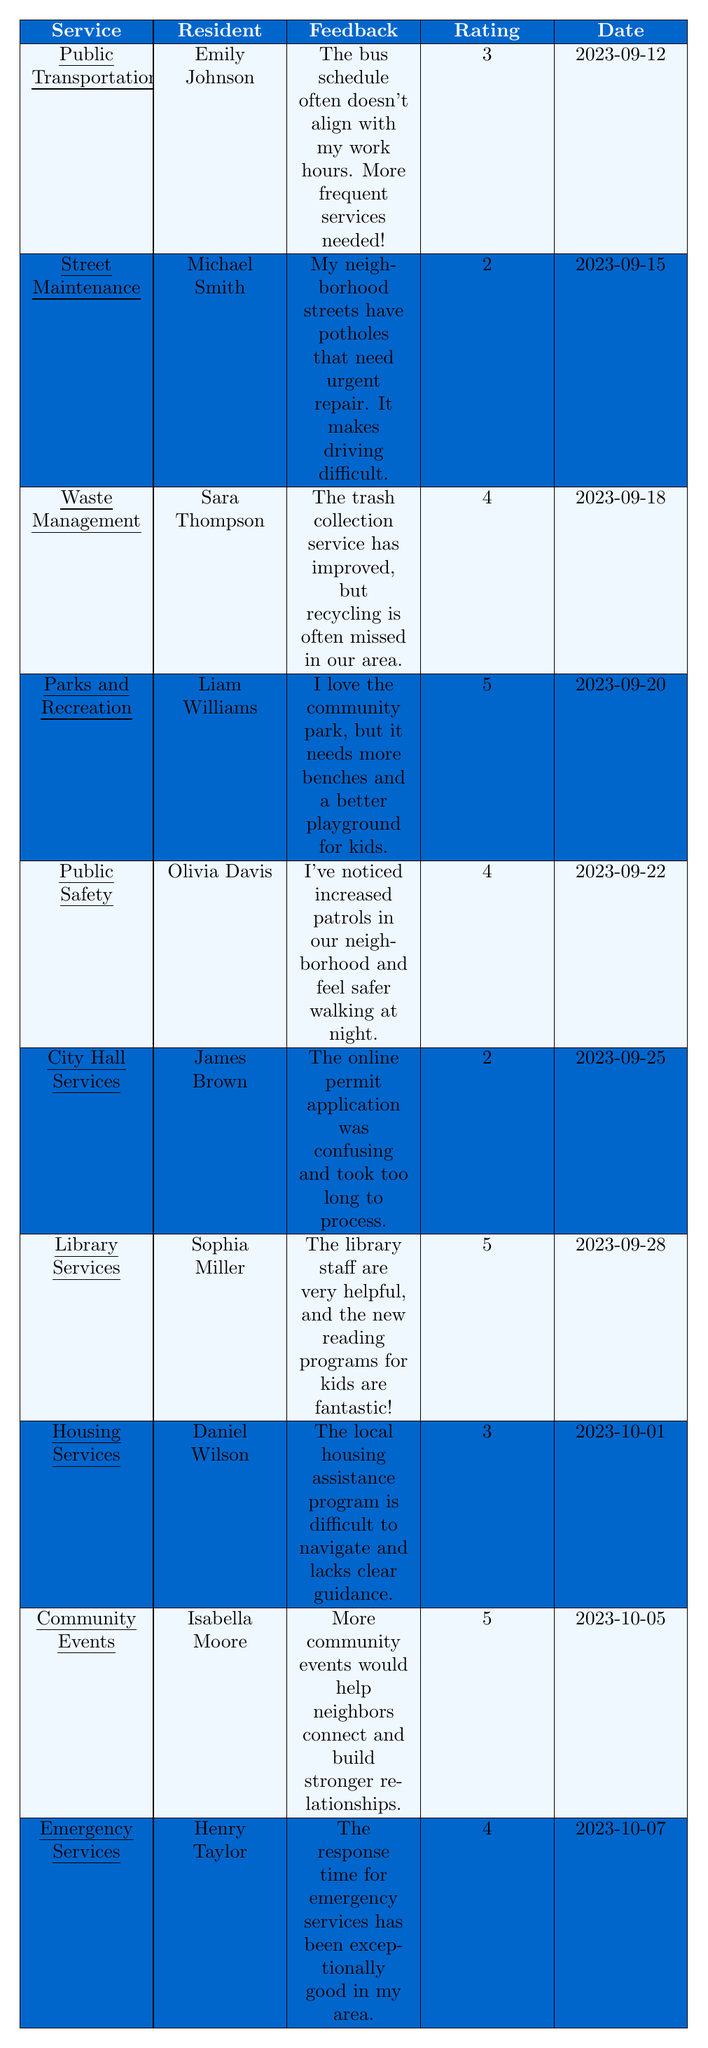What is the feedback given by Sara Thompson? According to the table, Sara Thompson provided feedback on Waste Management, stating that the trash collection service has improved, but recycling is often missed in their area.
Answer: Feedback on Waste Management: "The trash collection service has improved, but recycling is often missed in our area." Which service received the highest rating? From the table, Parks and Recreation, Library Services, and Community Events each received a rating of 5, which is the highest rating given.
Answer: Parks and Recreation, Library Services, Community Events How many services received a rating of 4 or higher? The table shows four services with ratings of 4 or higher: Waste Management, Parks and Recreation, Public Safety, Library Services, Community Events, and Emergency Services (totaling 6 services).
Answer: 6 services What was the date of the feedback from Michael Smith? Michael Smith provided feedback on Street Maintenance, and it is noted in the table that his feedback was dated 2023-09-15.
Answer: 2023-09-15 Did any resident rate a service lower than 3? Yes, two residents rated services below 3; Michael Smith rated Street Maintenance with a 2, and James Brown rated City Hall Services also with a 2.
Answer: Yes What is the average rating of the services listed in the table? To calculate the average rating, we can add all the ratings together: (3 + 2 + 4 + 5 + 4 + 2 + 5 + 3 + 5 + 4) = 43. There are 10 services in total, so the average rating is 43/10 = 4.3.
Answer: 4.3 Which service has feedback indicating a need for more frequent services? The feedback from Emily Johnson indicates that Public Transportation needs more frequent services because the bus schedule does not align with her work hours.
Answer: Public Transportation What percentage of residents provided positive feedback (rating of 4 or 5)? The table contains 10 feedback entries, of which 5 ratings are 4 or 5 (Waste Management, Parks and Recreation, Library Services, Community Events, Emergency Services). The percentage is (5/10) * 100 = 50%.
Answer: 50% Who expressed concern about the online permit application process? James Brown provided feedback regarding City Hall Services, expressing that the online permit application was confusing and took too long to process.
Answer: James Brown Based on the feedback, which service is most appreciated and could focus on community building? Community Events received the highest rating (5) and feedback from Isabella Moore, who emphasized that more events would help neighbors connect and build stronger relationships, indicating it is appreciated and could enhance community building.
Answer: Community Events 